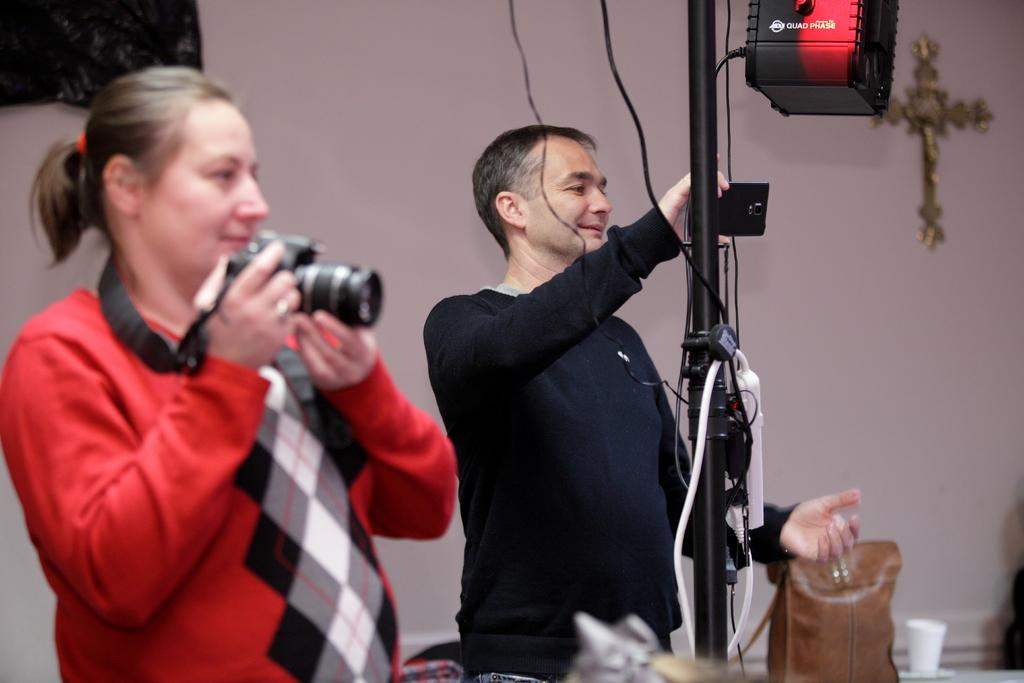What is the woman in the image holding? The woman is holding a camera. What is the man in the image holding? The man is holding a mobile. What is the man doing in the image? The man is laughing. What objects can be seen in the background of the image? There is a bag, a cup, and a wall in the background of the image. Is there any blood visible in the image? No, there is no blood present in the image. Is there any smoke visible in the image? No, there is no smoke present in the image. 